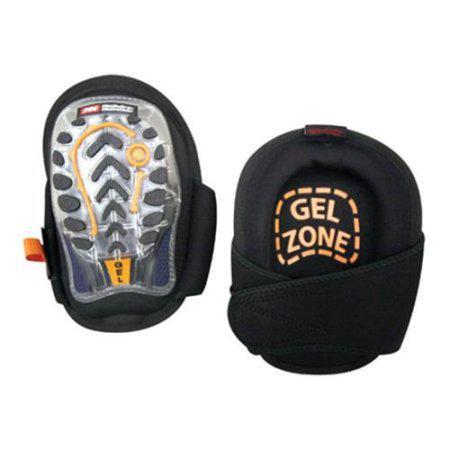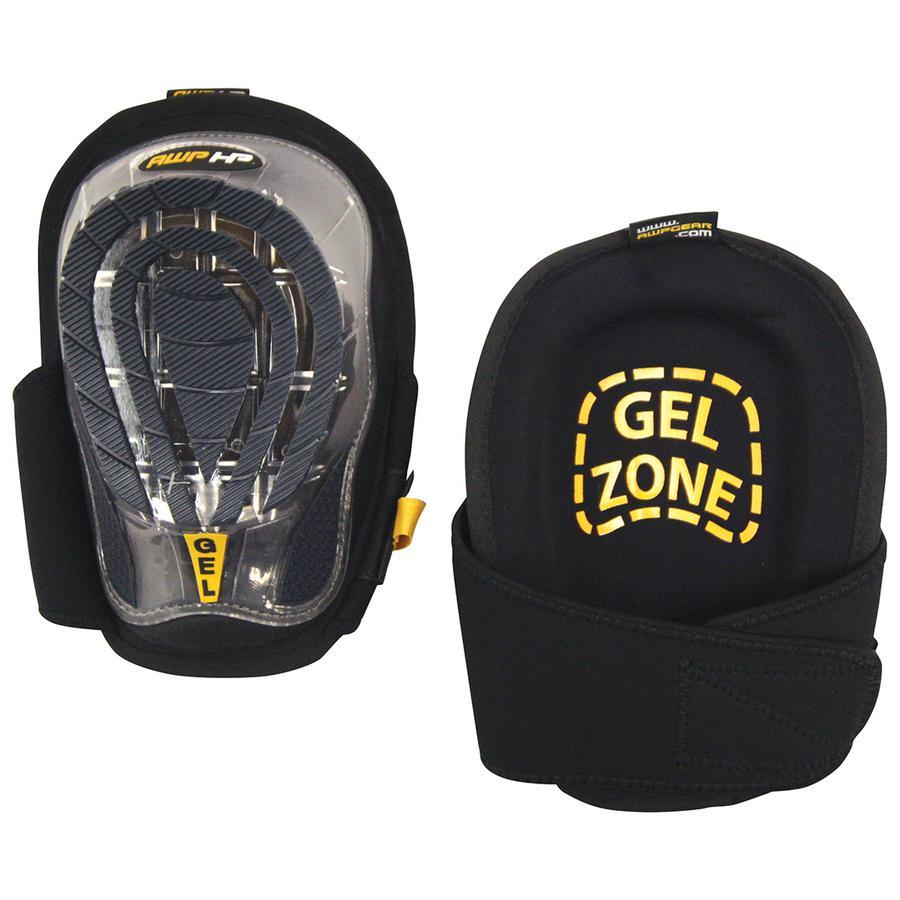The first image is the image on the left, the second image is the image on the right. Assess this claim about the two images: "In the image on the right, you can clearly see the label that designates which knee this pad goes on.". Correct or not? Answer yes or no. No. The first image is the image on the left, the second image is the image on the right. Analyze the images presented: Is the assertion "At least one knee pad tells you which knee to put it on." valid? Answer yes or no. No. 